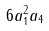Convert formula to latex. <formula><loc_0><loc_0><loc_500><loc_500>6 a _ { 1 } ^ { 2 } a _ { 4 }</formula> 